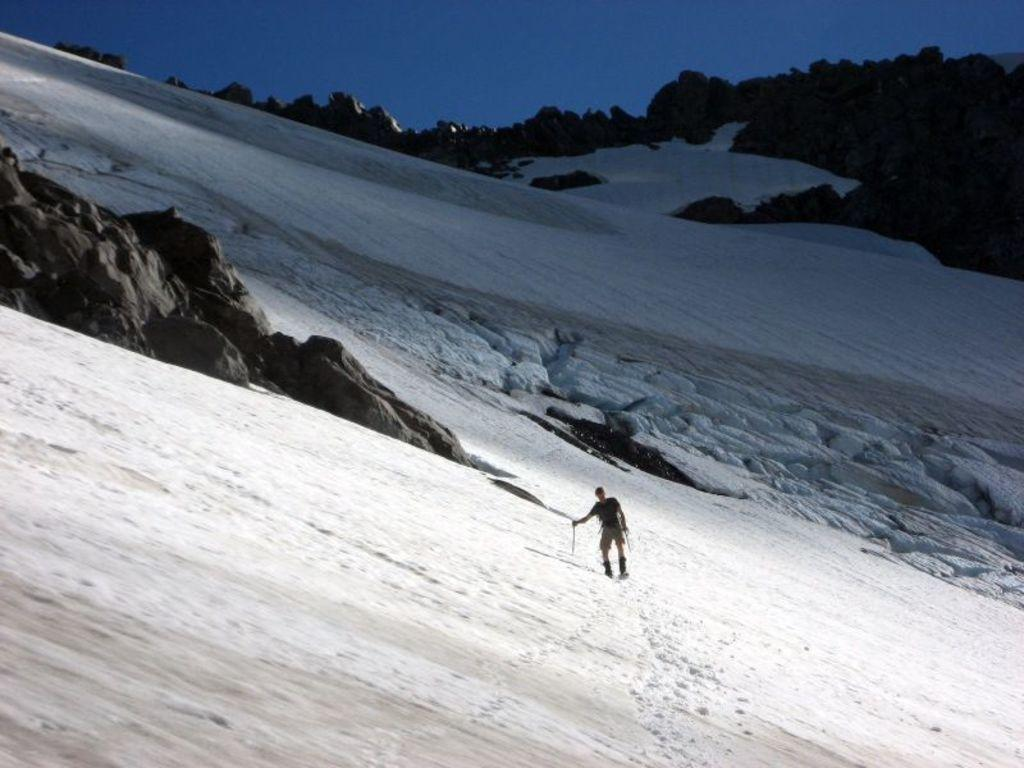What is the condition of the land in the image? The land is covered with snow. What can be seen in the middle of the image? There is a person in the middle of the image. What type of natural features are visible in the background of the image? There are rocks in the background of the image. What is visible above the land and rocks in the image? The sky is visible in the image, and it is blue in color. What type of curtain can be seen hanging in the image? There is no curtain present in the image; it features a person standing on snow-covered land with rocks and a blue sky in the background. What time of day is it in the image, as indicated by the watch on the person's wrist? There is no watch visible on the person's wrist in the image. 